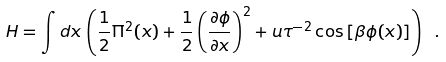Convert formula to latex. <formula><loc_0><loc_0><loc_500><loc_500>H = \int d x \, \left ( \frac { 1 } { 2 } \Pi ^ { 2 } ( x ) + \frac { 1 } { 2 } \left ( \frac { \partial \phi } { \partial x } \right ) ^ { 2 } + u \tau ^ { - 2 } \cos \left [ \beta \phi ( x ) \right ] \right ) \ .</formula> 